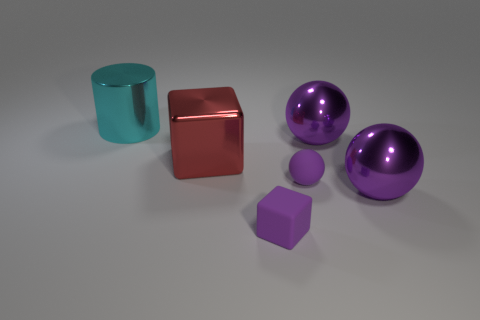Is the color of the tiny block the same as the tiny ball?
Your response must be concise. Yes. There is a small sphere that is the same color as the tiny cube; what is its material?
Provide a short and direct response. Rubber. Does the tiny thing behind the small block have the same color as the small cube?
Provide a succinct answer. Yes. The large sphere in front of the large purple metallic ball that is behind the rubber ball to the right of the large red shiny cube is what color?
Provide a succinct answer. Purple. Is there a shiny cylinder that is on the right side of the large purple sphere that is in front of the red shiny object?
Provide a succinct answer. No. Do the big shiny sphere that is behind the large red thing and the large metallic sphere that is in front of the red thing have the same color?
Make the answer very short. Yes. How many purple metallic things are the same size as the cyan cylinder?
Provide a short and direct response. 2. Does the rubber thing that is in front of the purple rubber sphere have the same size as the cyan metal thing?
Your response must be concise. No. What is the shape of the cyan metal thing?
Provide a succinct answer. Cylinder. Does the big ball that is behind the large block have the same material as the small purple sphere?
Give a very brief answer. No. 